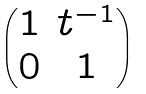Convert formula to latex. <formula><loc_0><loc_0><loc_500><loc_500>\begin{pmatrix} 1 & t ^ { - 1 } \\ 0 & 1 \end{pmatrix}</formula> 